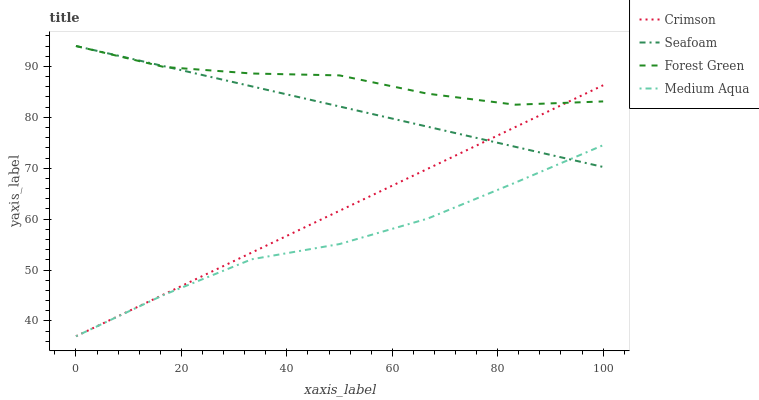Does Forest Green have the minimum area under the curve?
Answer yes or no. No. Does Medium Aqua have the maximum area under the curve?
Answer yes or no. No. Is Medium Aqua the smoothest?
Answer yes or no. No. Is Medium Aqua the roughest?
Answer yes or no. No. Does Forest Green have the lowest value?
Answer yes or no. No. Does Medium Aqua have the highest value?
Answer yes or no. No. Is Medium Aqua less than Forest Green?
Answer yes or no. Yes. Is Forest Green greater than Medium Aqua?
Answer yes or no. Yes. Does Medium Aqua intersect Forest Green?
Answer yes or no. No. 